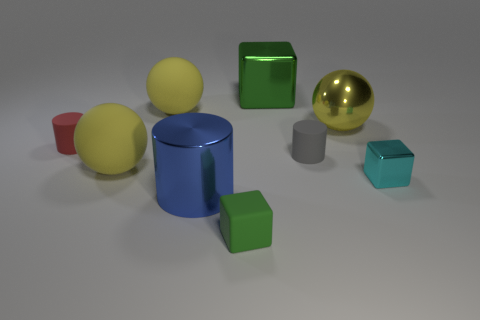Subtract all blocks. How many objects are left? 6 Subtract all gray matte objects. Subtract all big yellow objects. How many objects are left? 5 Add 5 blue shiny things. How many blue shiny things are left? 6 Add 6 brown metal cylinders. How many brown metal cylinders exist? 6 Subtract 0 red blocks. How many objects are left? 9 